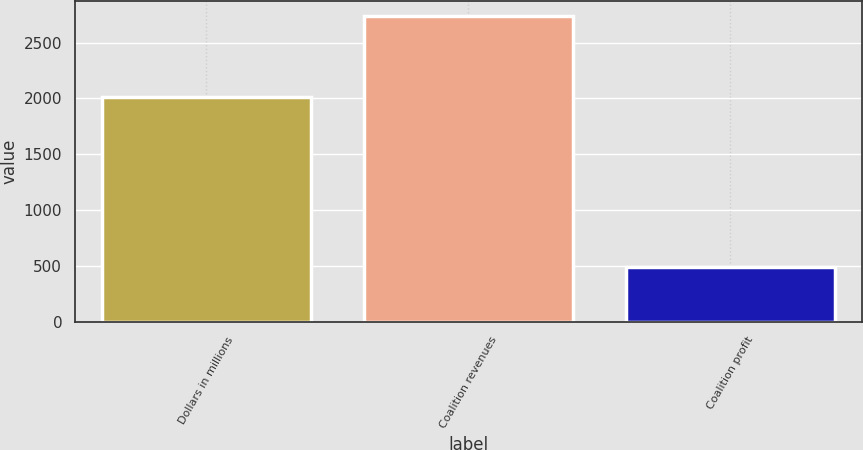Convert chart to OTSL. <chart><loc_0><loc_0><loc_500><loc_500><bar_chart><fcel>Dollars in millions<fcel>Coalition revenues<fcel>Coalition profit<nl><fcel>2016<fcel>2737.7<fcel>491.9<nl></chart> 